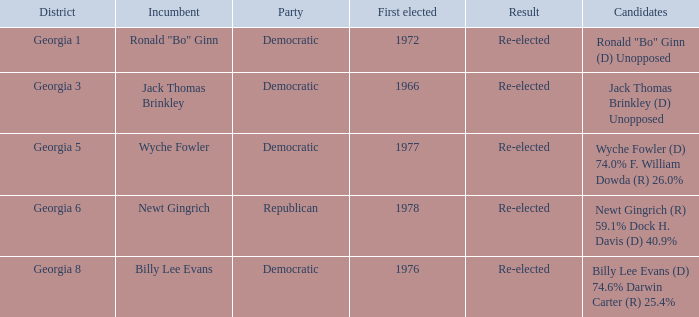In 1972, how many candidates were elected for the first time? 1.0. 